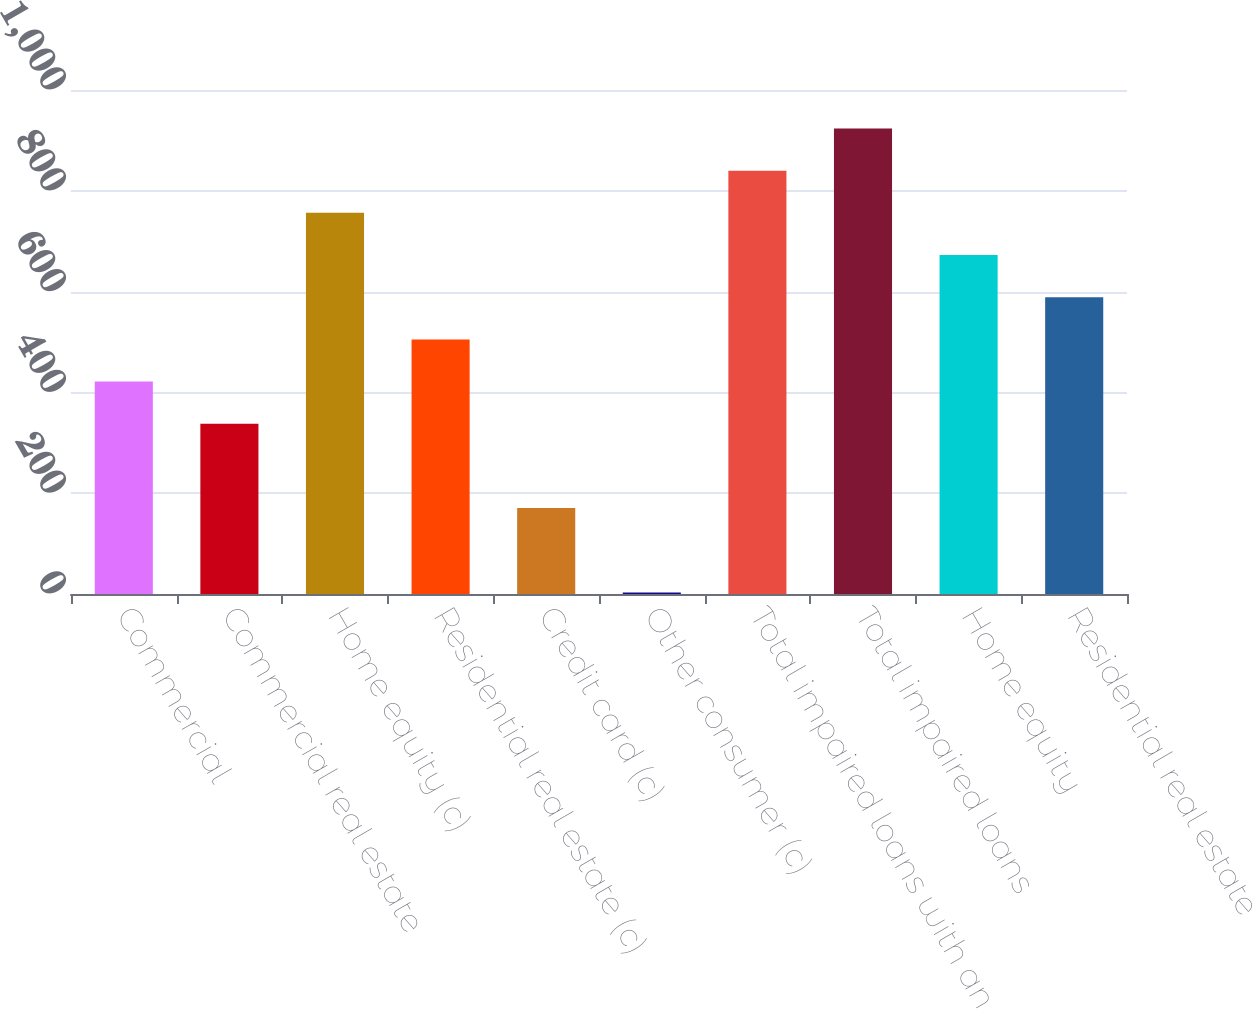<chart> <loc_0><loc_0><loc_500><loc_500><bar_chart><fcel>Commercial<fcel>Commercial real estate<fcel>Home equity (c)<fcel>Residential real estate (c)<fcel>Credit card (c)<fcel>Other consumer (c)<fcel>Total impaired loans with an<fcel>Total impaired loans<fcel>Home equity<fcel>Residential real estate<nl><fcel>421.5<fcel>337.8<fcel>756.3<fcel>505.2<fcel>170.4<fcel>3<fcel>840<fcel>923.7<fcel>672.6<fcel>588.9<nl></chart> 